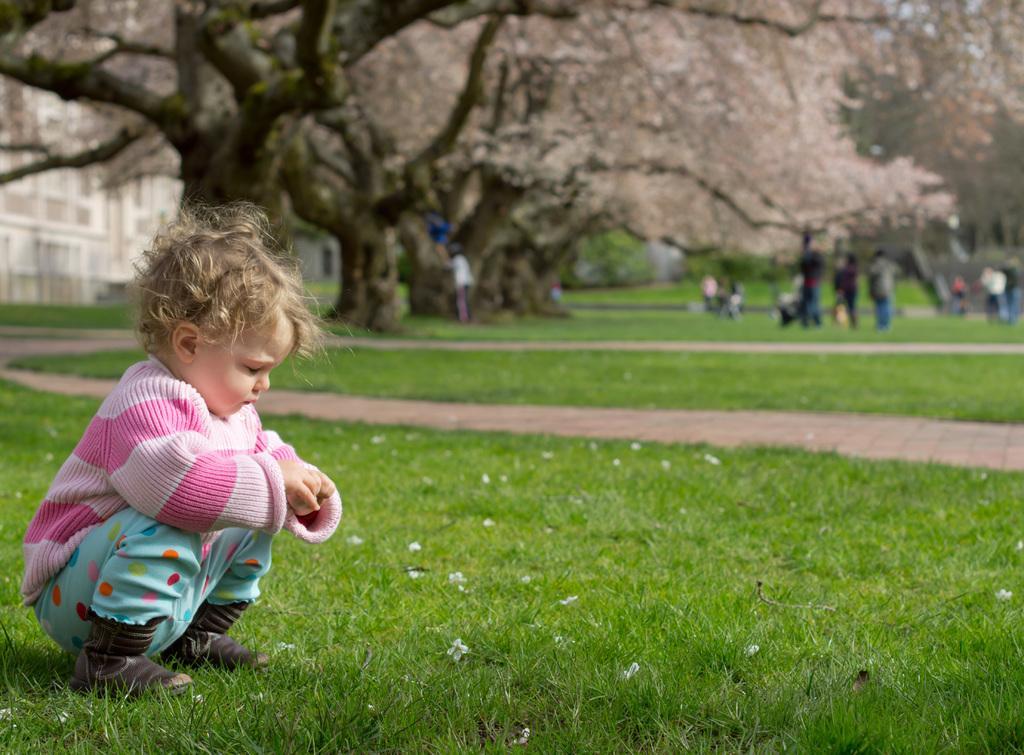Please provide a concise description of this image. In the foreground of the picture there is a kid playing in the grass. In the background there are trees, people, grass and building. 